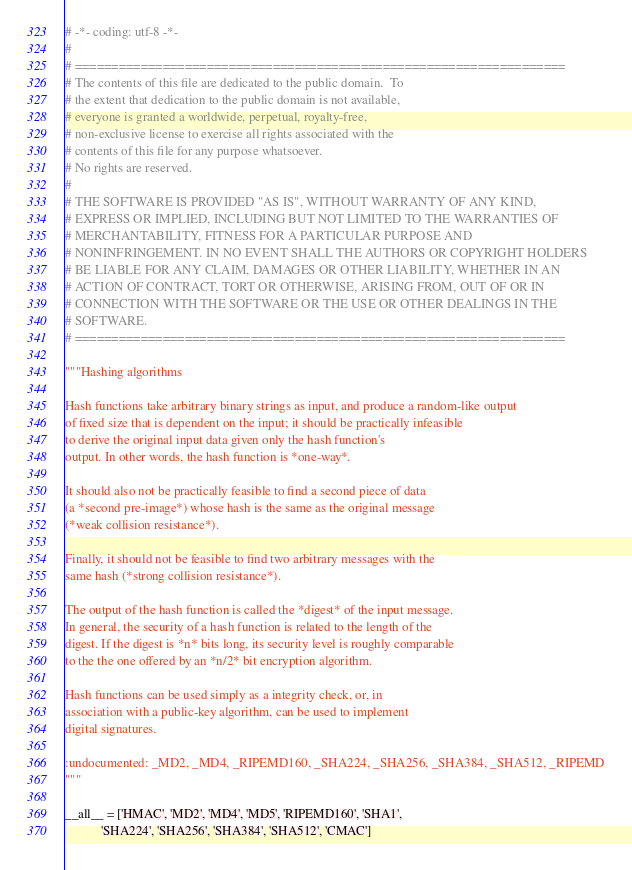Convert code to text. <code><loc_0><loc_0><loc_500><loc_500><_Python_># -*- coding: utf-8 -*-
#
# ===================================================================
# The contents of this file are dedicated to the public domain.  To
# the extent that dedication to the public domain is not available,
# everyone is granted a worldwide, perpetual, royalty-free,
# non-exclusive license to exercise all rights associated with the
# contents of this file for any purpose whatsoever.
# No rights are reserved.
#
# THE SOFTWARE IS PROVIDED "AS IS", WITHOUT WARRANTY OF ANY KIND,
# EXPRESS OR IMPLIED, INCLUDING BUT NOT LIMITED TO THE WARRANTIES OF
# MERCHANTABILITY, FITNESS FOR A PARTICULAR PURPOSE AND
# NONINFRINGEMENT. IN NO EVENT SHALL THE AUTHORS OR COPYRIGHT HOLDERS
# BE LIABLE FOR ANY CLAIM, DAMAGES OR OTHER LIABILITY, WHETHER IN AN
# ACTION OF CONTRACT, TORT OR OTHERWISE, ARISING FROM, OUT OF OR IN
# CONNECTION WITH THE SOFTWARE OR THE USE OR OTHER DEALINGS IN THE
# SOFTWARE.
# ===================================================================

"""Hashing algorithms

Hash functions take arbitrary binary strings as input, and produce a random-like output
of fixed size that is dependent on the input; it should be practically infeasible
to derive the original input data given only the hash function's
output. In other words, the hash function is *one-way*.

It should also not be practically feasible to find a second piece of data
(a *second pre-image*) whose hash is the same as the original message
(*weak collision resistance*).

Finally, it should not be feasible to find two arbitrary messages with the
same hash (*strong collision resistance*).

The output of the hash function is called the *digest* of the input message.
In general, the security of a hash function is related to the length of the
digest. If the digest is *n* bits long, its security level is roughly comparable
to the the one offered by an *n/2* bit encryption algorithm.

Hash functions can be used simply as a integrity check, or, in
association with a public-key algorithm, can be used to implement
digital signatures.

:undocumented: _MD2, _MD4, _RIPEMD160, _SHA224, _SHA256, _SHA384, _SHA512, _RIPEMD
"""

__all__ = ['HMAC', 'MD2', 'MD4', 'MD5', 'RIPEMD160', 'SHA1',
           'SHA224', 'SHA256', 'SHA384', 'SHA512', 'CMAC']
</code> 